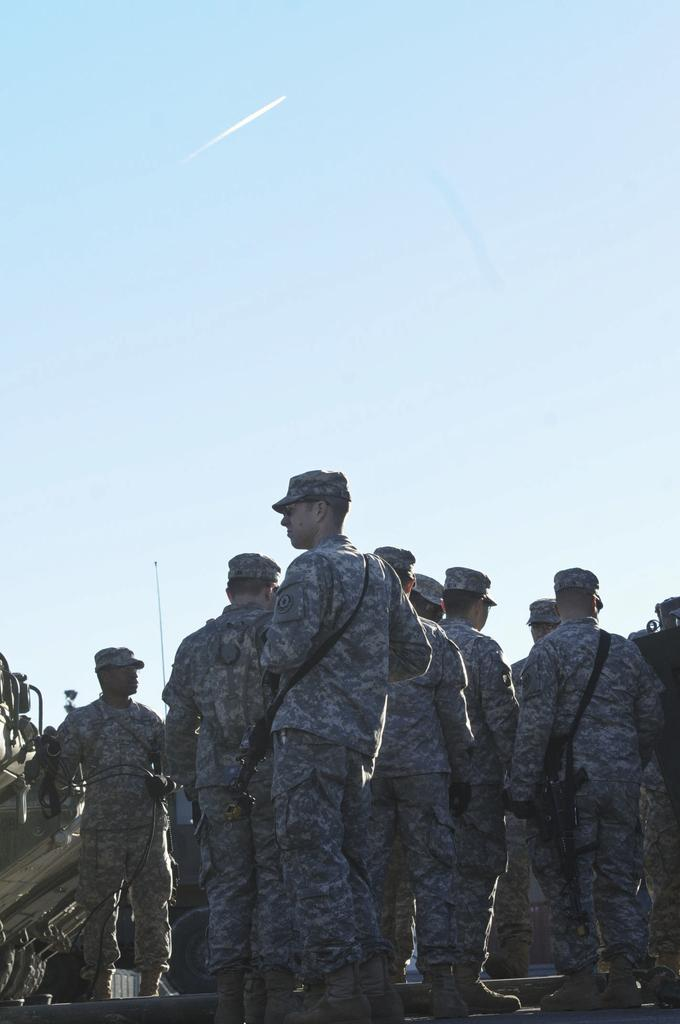What is the main subject of the image? The main subject of the image is a group of men. What are the men wearing in the image? The men are wearing caps in the image. What are the men holding in their hands? The men are holding guns in their hands. What can be seen in the background of the image? The sky is visible in the background of the image. What type of credit card is visible in the image? There is no credit card present in the image. What is the wire used for in the image? There is no wire present in the image. 